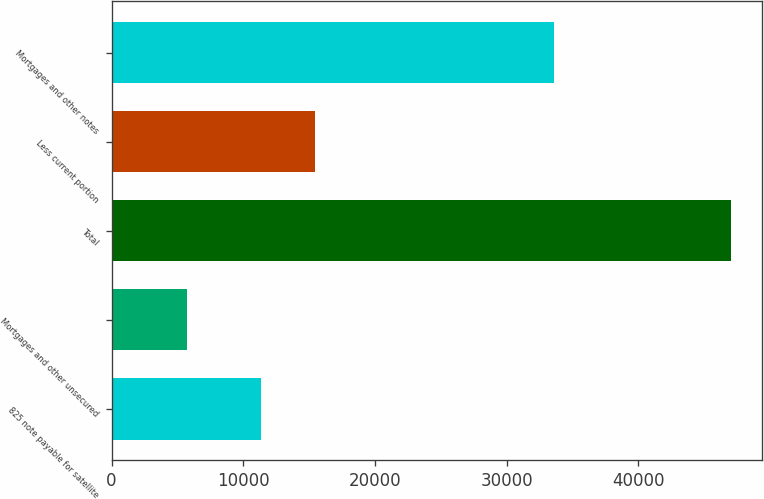Convert chart. <chart><loc_0><loc_0><loc_500><loc_500><bar_chart><fcel>825 note payable for satellite<fcel>Mortgages and other unsecured<fcel>Total<fcel>Less current portion<fcel>Mortgages and other notes<nl><fcel>11327<fcel>5726<fcel>47053<fcel>15459.7<fcel>33621<nl></chart> 